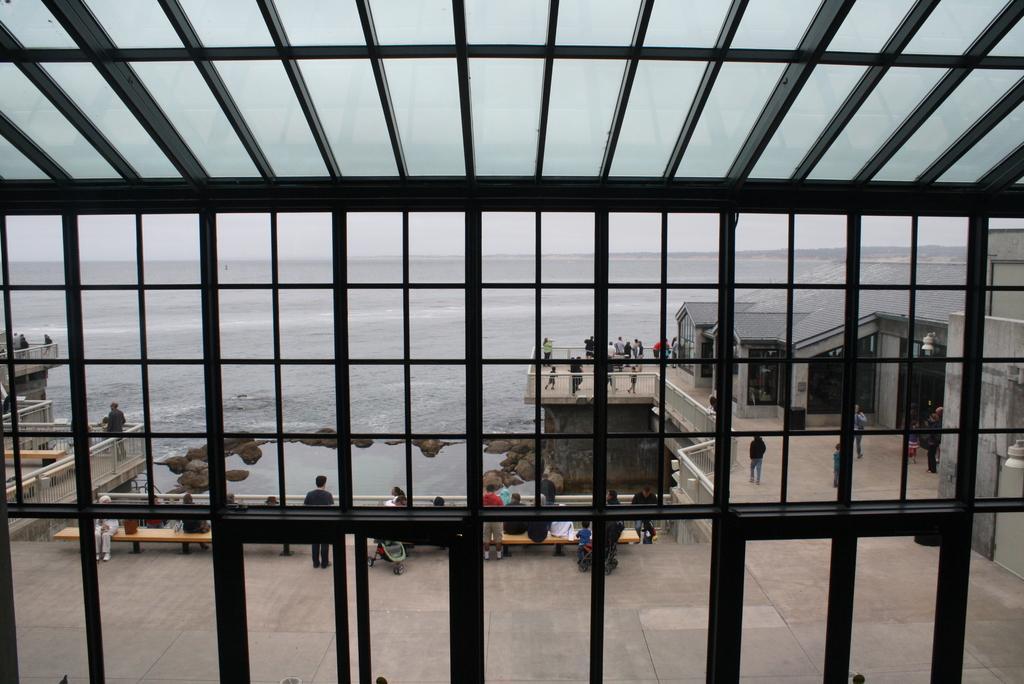In one or two sentences, can you explain what this image depicts? In this picture we can see roads, buildings and some people are sitting on benches and some people are standing on a surface, rocks and some objects and in the background we can see water, sky. 